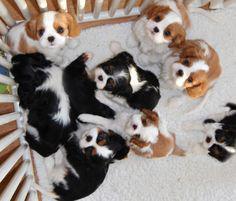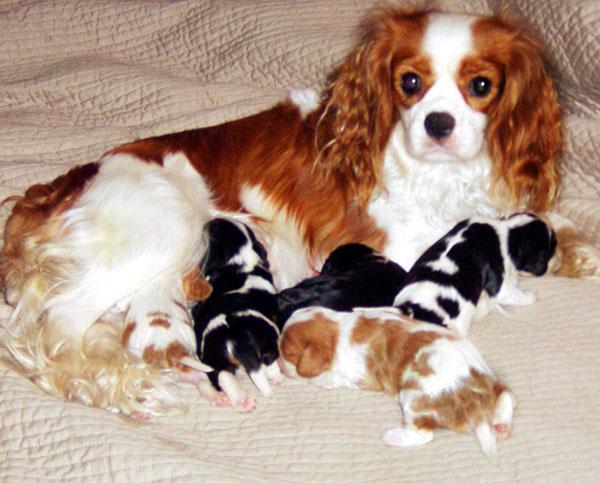The first image is the image on the left, the second image is the image on the right. Assess this claim about the two images: "The right image shows an adult, brown and white colored cocker spaniel mom with multiple puppies nursing". Correct or not? Answer yes or no. Yes. 